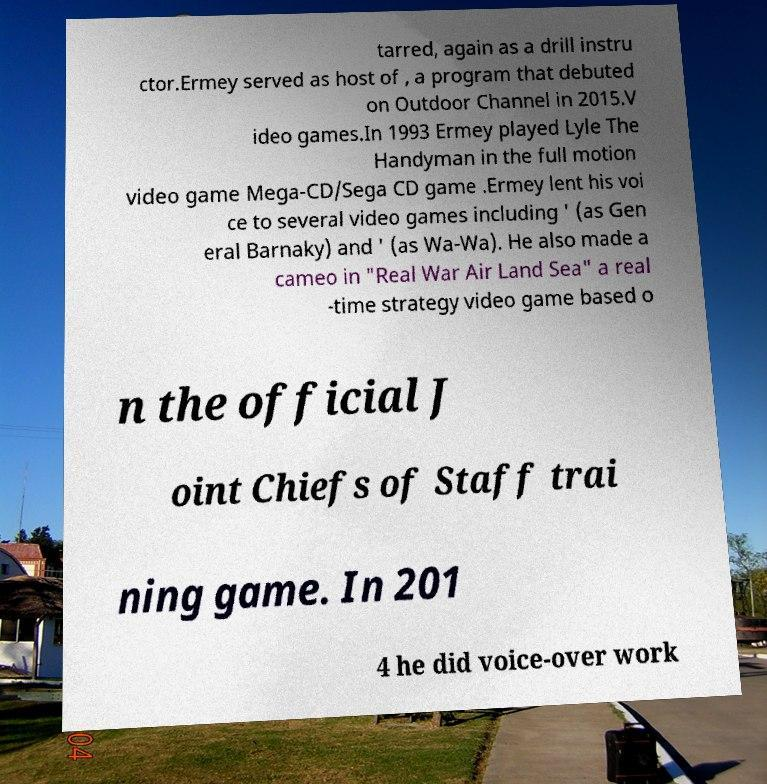What messages or text are displayed in this image? I need them in a readable, typed format. tarred, again as a drill instru ctor.Ermey served as host of , a program that debuted on Outdoor Channel in 2015.V ideo games.In 1993 Ermey played Lyle The Handyman in the full motion video game Mega-CD/Sega CD game .Ermey lent his voi ce to several video games including ' (as Gen eral Barnaky) and ' (as Wa-Wa). He also made a cameo in "Real War Air Land Sea" a real -time strategy video game based o n the official J oint Chiefs of Staff trai ning game. In 201 4 he did voice-over work 